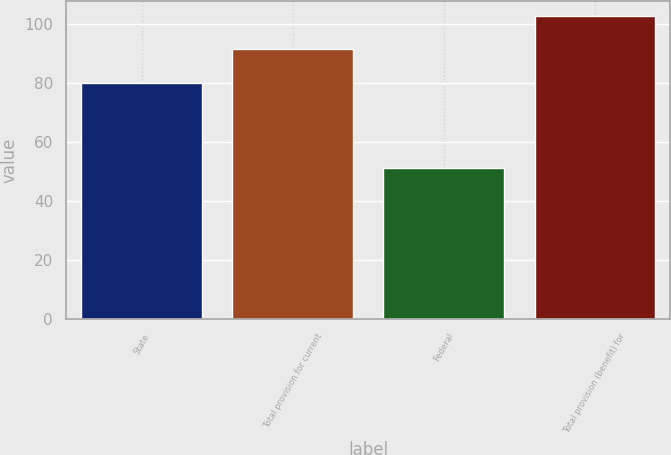Convert chart. <chart><loc_0><loc_0><loc_500><loc_500><bar_chart><fcel>State<fcel>Total provision for current<fcel>Federal<fcel>Total provision (benefit) for<nl><fcel>80<fcel>91.3<fcel>51<fcel>102.6<nl></chart> 